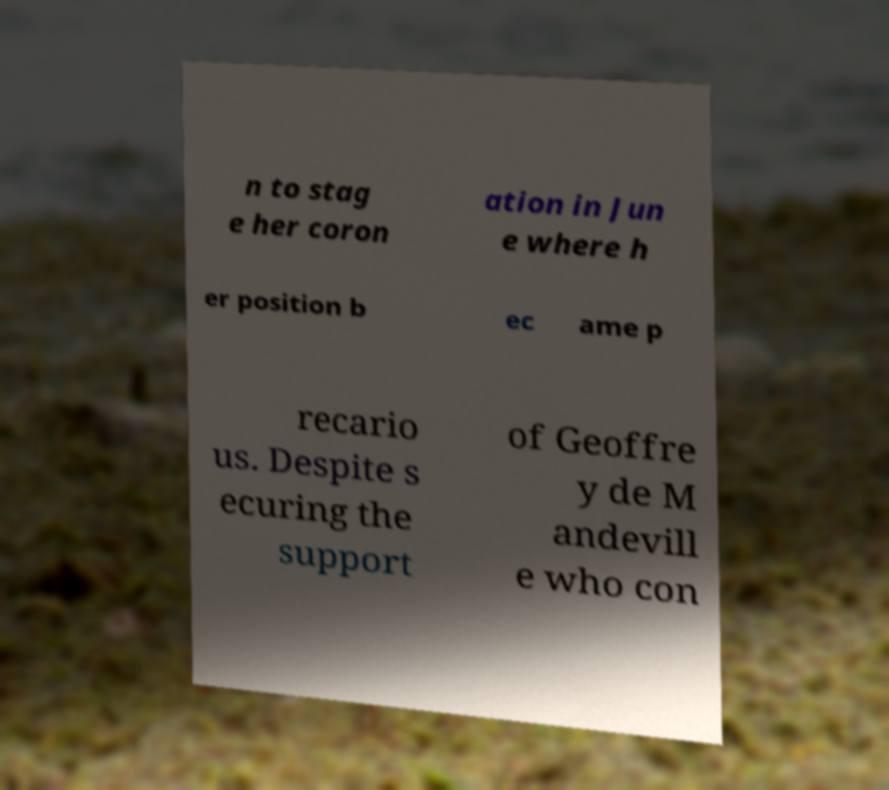Please read and relay the text visible in this image. What does it say? n to stag e her coron ation in Jun e where h er position b ec ame p recario us. Despite s ecuring the support of Geoffre y de M andevill e who con 